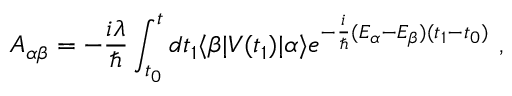Convert formula to latex. <formula><loc_0><loc_0><loc_500><loc_500>A _ { \alpha \beta } = - { \frac { i \lambda } { } } \int _ { t _ { 0 } } ^ { t } d t _ { 1 } \langle \beta | V ( t _ { 1 } ) | \alpha \rangle e ^ { - { \frac { i } { } } ( E _ { \alpha } - E _ { \beta } ) ( t _ { 1 } - t _ { 0 } ) } ,</formula> 